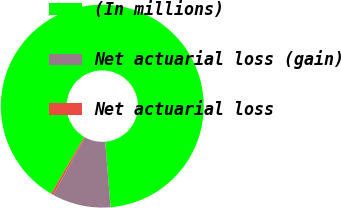Convert chart to OTSL. <chart><loc_0><loc_0><loc_500><loc_500><pie_chart><fcel>(In millions)<fcel>Net actuarial loss (gain)<fcel>Net actuarial loss<nl><fcel>90.29%<fcel>9.35%<fcel>0.36%<nl></chart> 